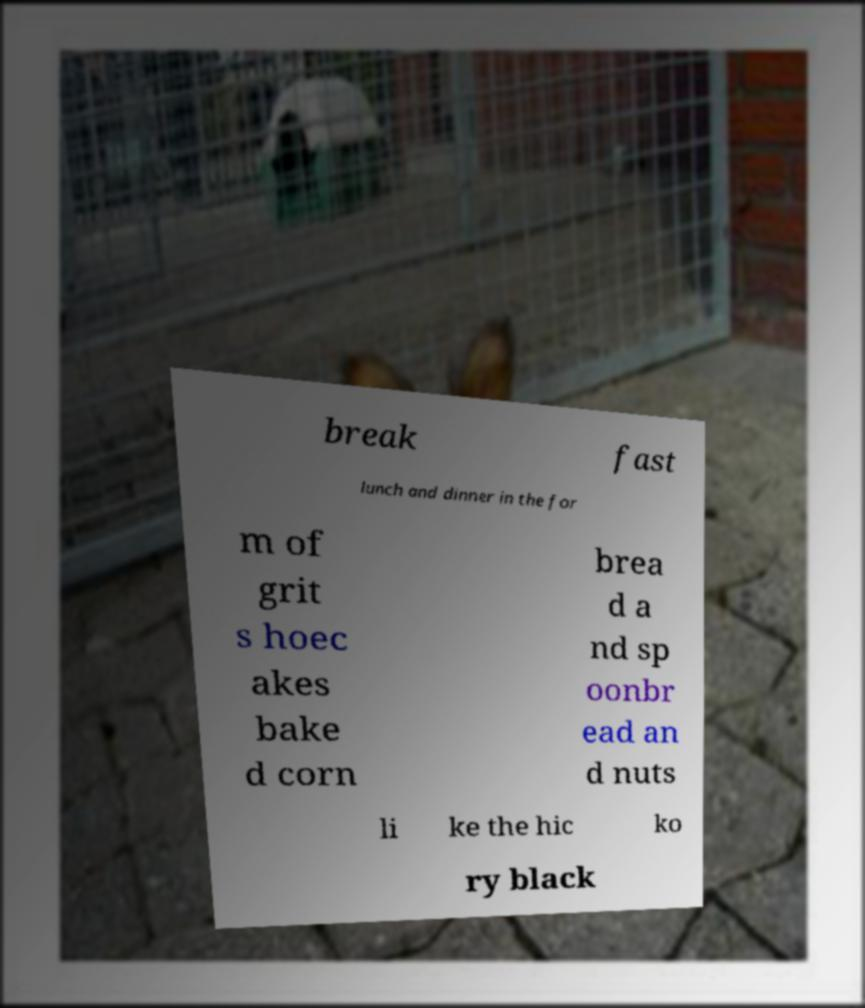Can you read and provide the text displayed in the image?This photo seems to have some interesting text. Can you extract and type it out for me? break fast lunch and dinner in the for m of grit s hoec akes bake d corn brea d a nd sp oonbr ead an d nuts li ke the hic ko ry black 